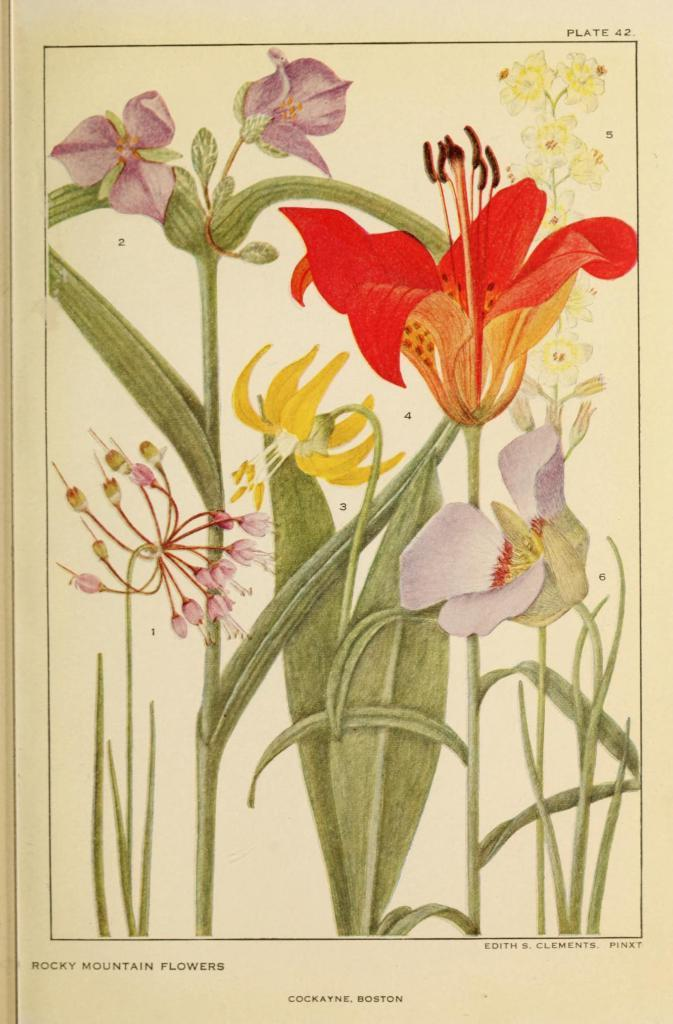What is the main subject of the image? The image contains a painting. What types of flora are depicted in the painting? The painting includes flowers and plants. Is there any text associated with the painting in the image? Yes, there is text at the bottom of the image. How does the steam from the pin affect the painting in the image? There is no steam or pin present in the image, so this question cannot be answered. 